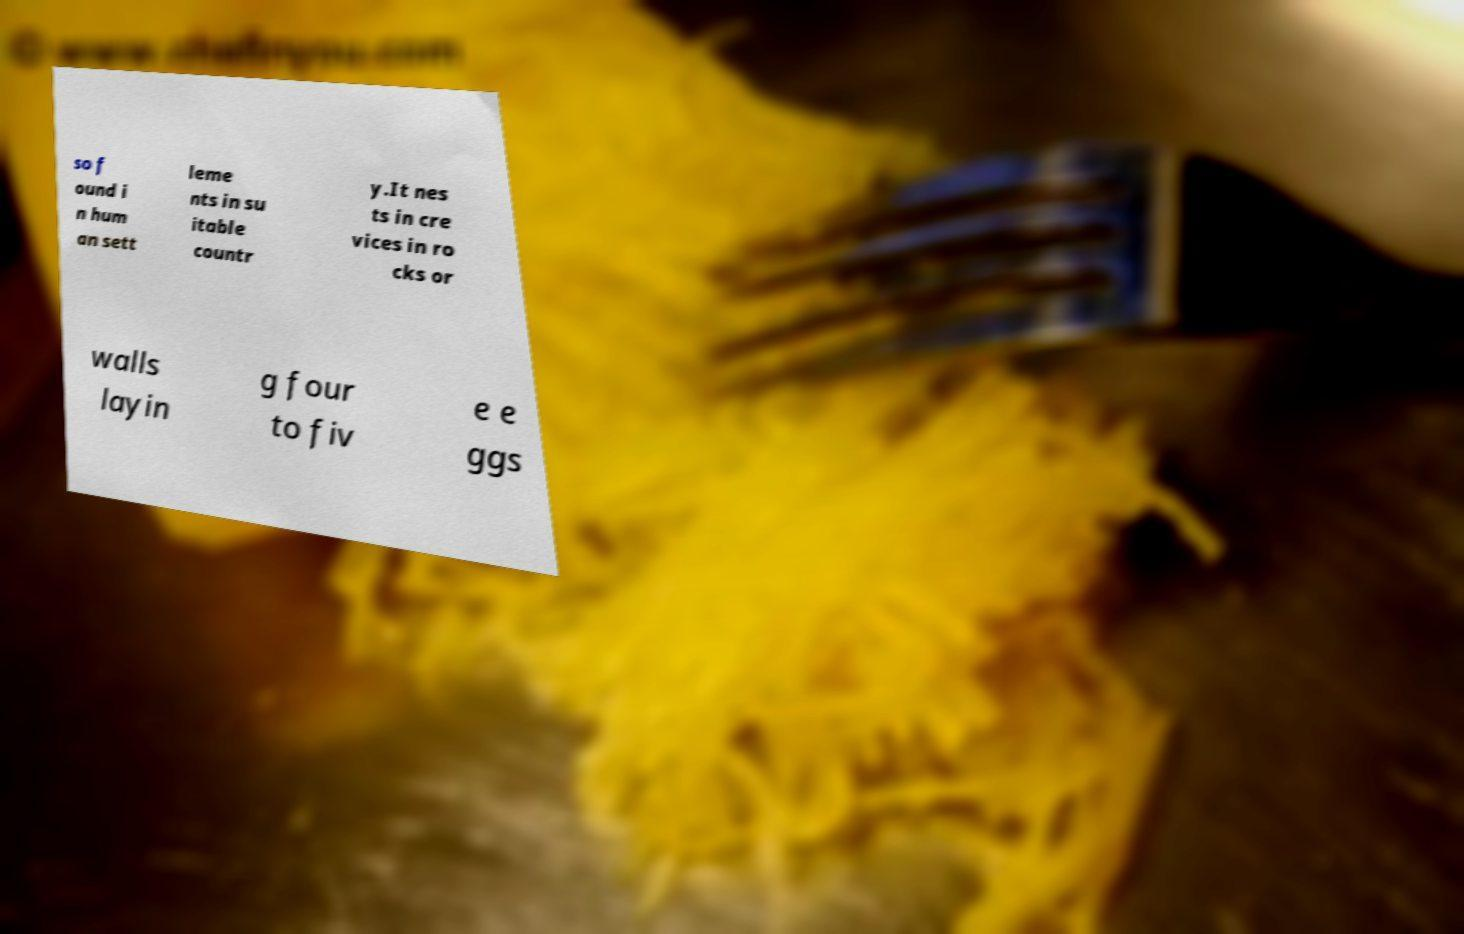For documentation purposes, I need the text within this image transcribed. Could you provide that? so f ound i n hum an sett leme nts in su itable countr y.It nes ts in cre vices in ro cks or walls layin g four to fiv e e ggs 